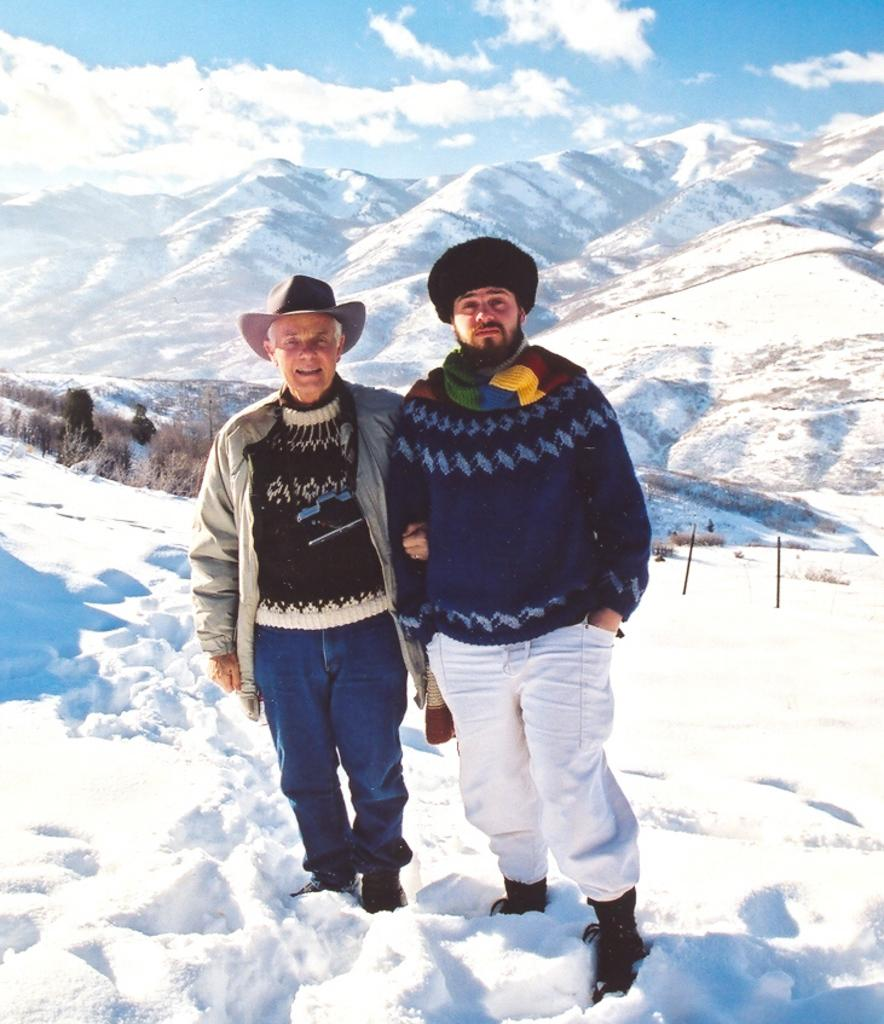How many people are in the image? There are two persons in the image. What is the surface they are standing on? The persons are standing on a snowy surface. What can be seen in the background of the image? There are trees and mountains in the background of the image. What is visible in the sky? There are clouds in the sky. What type of disgust can be seen on the faces of the persons in the image? There is no indication of disgust on the faces of the persons in the image. What range of colors can be seen in the image? The image primarily features shades of white, blue, and green, with some brown from the trees and mountains. However, there is no specific range of colors mentioned in the facts. 